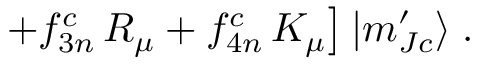<formula> <loc_0><loc_0><loc_500><loc_500>+ f _ { 3 n } ^ { c } \, R _ { \mu } + f _ { 4 n } ^ { c } \, K _ { \mu } \right ] | m _ { J c } ^ { \prime } \rangle \, .</formula> 